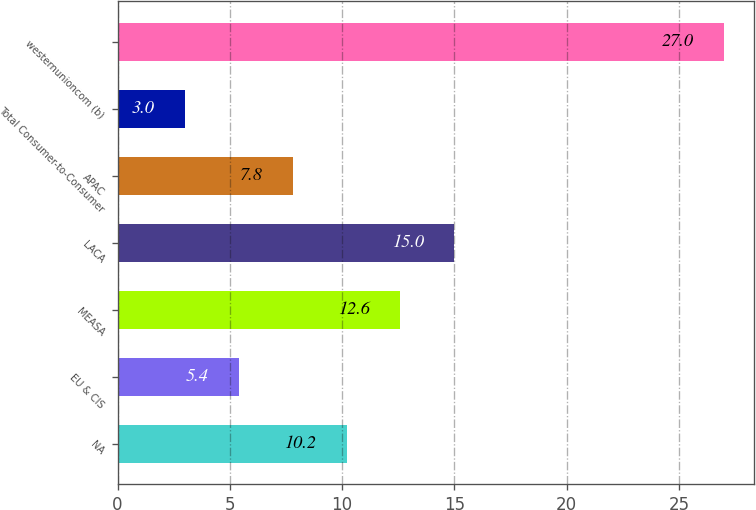Convert chart to OTSL. <chart><loc_0><loc_0><loc_500><loc_500><bar_chart><fcel>NA<fcel>EU & CIS<fcel>MEASA<fcel>LACA<fcel>APAC<fcel>Total Consumer-to-Consumer<fcel>westernunioncom (b)<nl><fcel>10.2<fcel>5.4<fcel>12.6<fcel>15<fcel>7.8<fcel>3<fcel>27<nl></chart> 